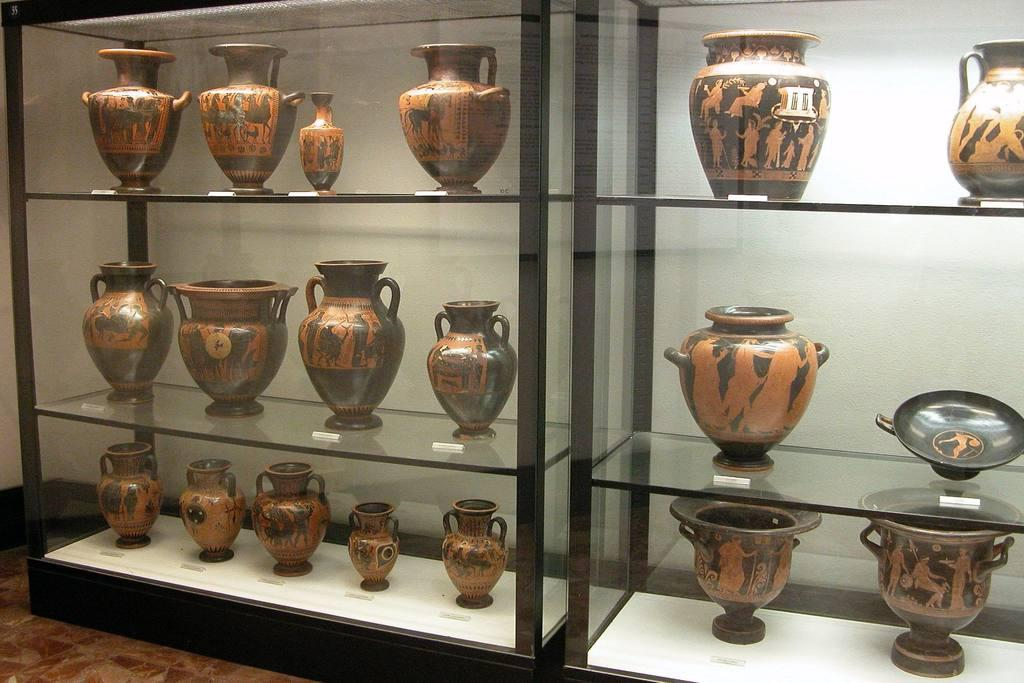What type of containers are visible in the image? There are pots and jars in the image. Where are the pots and jars located? The pots and jars are placed in cupboards. What type of corn is being stored in the pots in the image? There is no corn visible in the image; it only shows pots and jars placed in cupboards. 